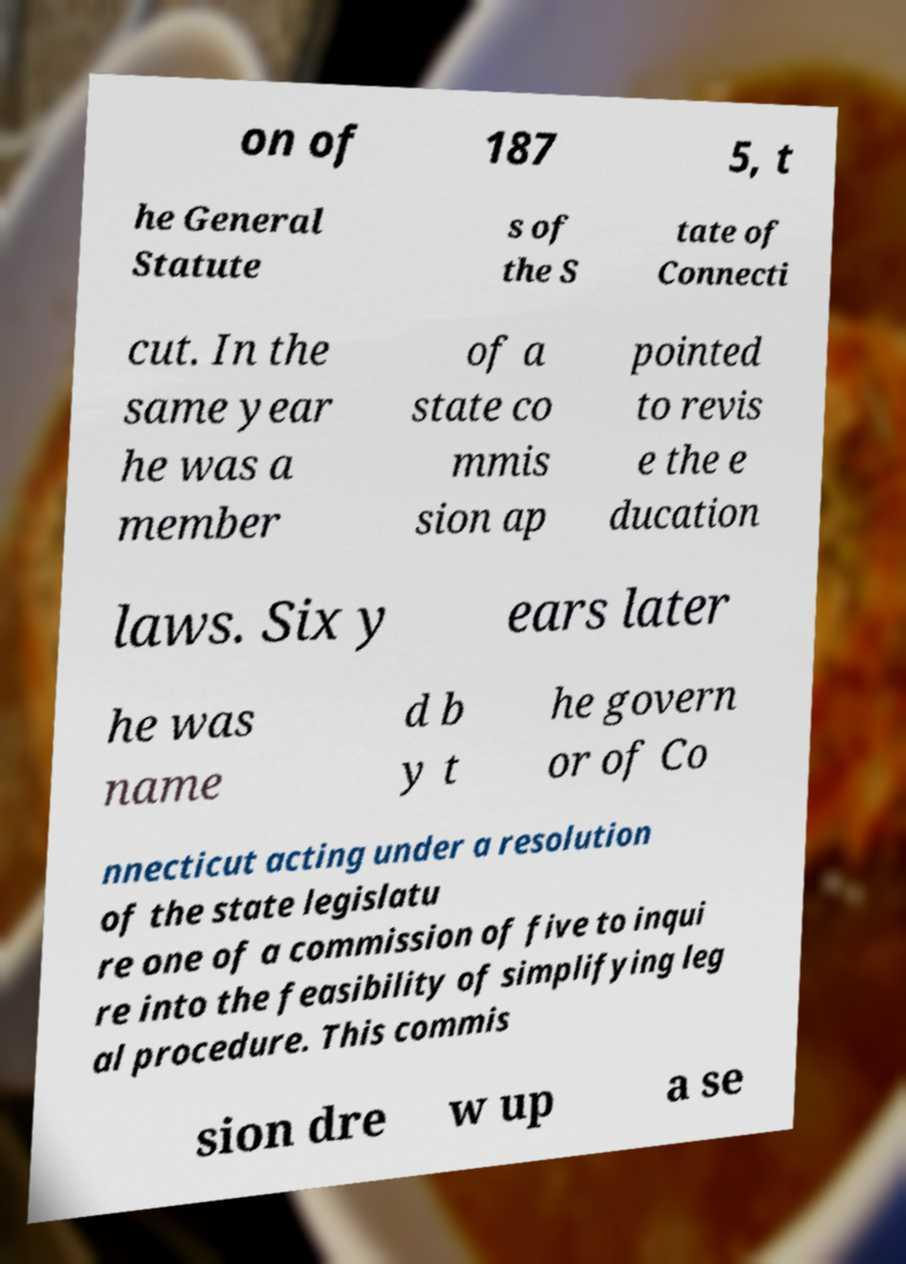There's text embedded in this image that I need extracted. Can you transcribe it verbatim? on of 187 5, t he General Statute s of the S tate of Connecti cut. In the same year he was a member of a state co mmis sion ap pointed to revis e the e ducation laws. Six y ears later he was name d b y t he govern or of Co nnecticut acting under a resolution of the state legislatu re one of a commission of five to inqui re into the feasibility of simplifying leg al procedure. This commis sion dre w up a se 